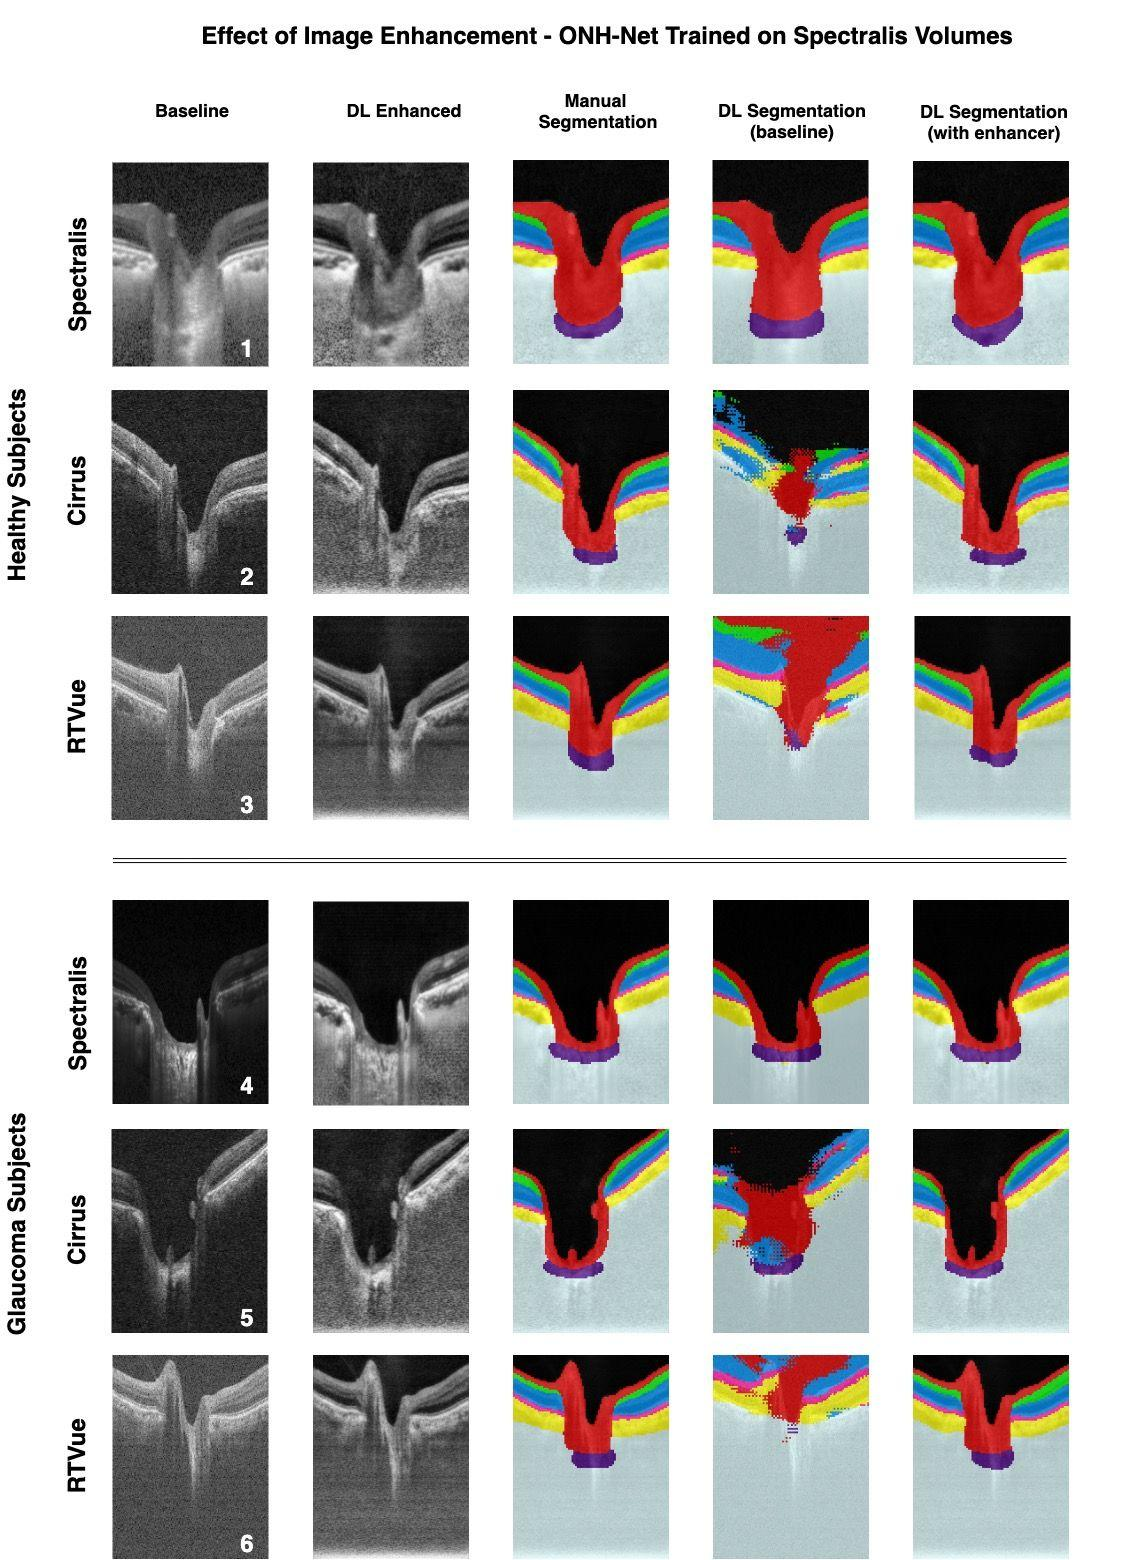What is the main purpose of the image enhancement technique as applied to the optical coherence tomography (OCT) images in this figure? In this figure, we can observe a clear distinction between the baseline optical coherence tomography (OCT) images and those that have undergone deep learning (DL) enhancement. The main intent behind such image enhancement is to amplify the visibility of specific structures within the images—in this case, the retinal layers. By utilizing sophisticated deep learning techniques, the contrast and sharpness of the retinal layers are significantly heightened, which allows for more precise segmentation. This detailed delineation is vital for medical analysis, as it provides clearer insights into the condition of the retina, which is essential for accurate diagnosis and treatment planning. 